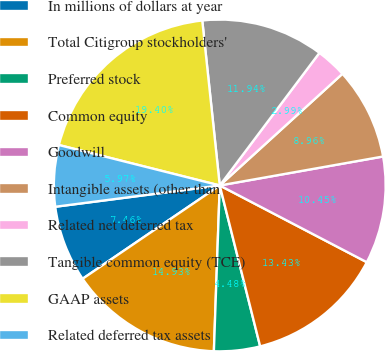Convert chart to OTSL. <chart><loc_0><loc_0><loc_500><loc_500><pie_chart><fcel>In millions of dollars at year<fcel>Total Citigroup stockholders'<fcel>Preferred stock<fcel>Common equity<fcel>Goodwill<fcel>Intangible assets (other than<fcel>Related net deferred tax<fcel>Tangible common equity (TCE)<fcel>GAAP assets<fcel>Related deferred tax assets<nl><fcel>7.46%<fcel>14.93%<fcel>4.48%<fcel>13.43%<fcel>10.45%<fcel>8.96%<fcel>2.99%<fcel>11.94%<fcel>19.4%<fcel>5.97%<nl></chart> 